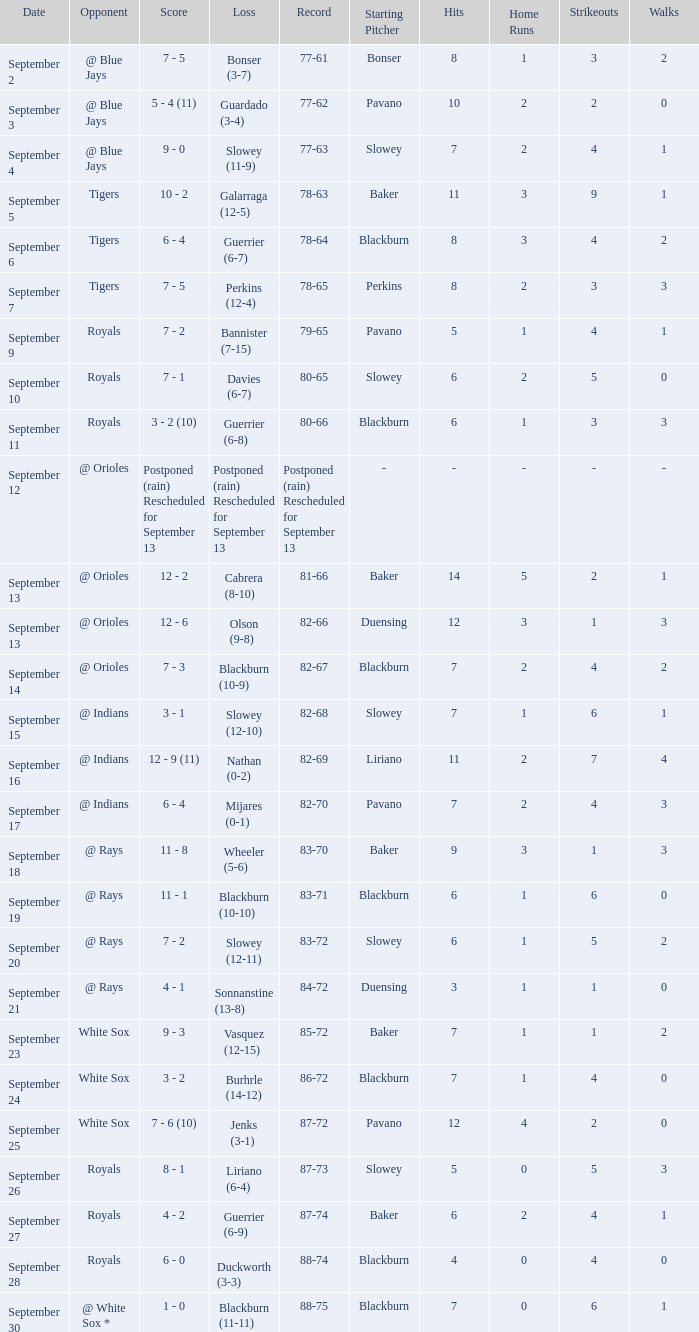What opponent has the record of 78-63? Tigers. 